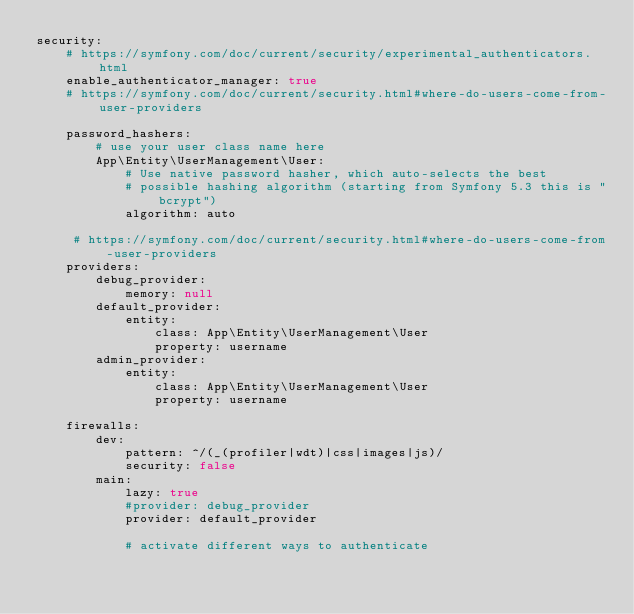<code> <loc_0><loc_0><loc_500><loc_500><_YAML_>security:
    # https://symfony.com/doc/current/security/experimental_authenticators.html
    enable_authenticator_manager: true
    # https://symfony.com/doc/current/security.html#where-do-users-come-from-user-providers
    
    password_hashers:
        # use your user class name here
        App\Entity\UserManagement\User:
            # Use native password hasher, which auto-selects the best
            # possible hashing algorithm (starting from Symfony 5.3 this is "bcrypt")
            algorithm: auto
            
     # https://symfony.com/doc/current/security.html#where-do-users-come-from-user-providers
    providers:
        debug_provider:
            memory: null
        default_provider:
            entity:
                class: App\Entity\UserManagement\User
                property: username
        admin_provider:
            entity:
                class: App\Entity\UserManagement\User
                property: username

    firewalls:
        dev:
            pattern: ^/(_(profiler|wdt)|css|images|js)/
            security: false
        main:
            lazy: true
            #provider: debug_provider
            provider: default_provider
            
            # activate different ways to authenticate</code> 